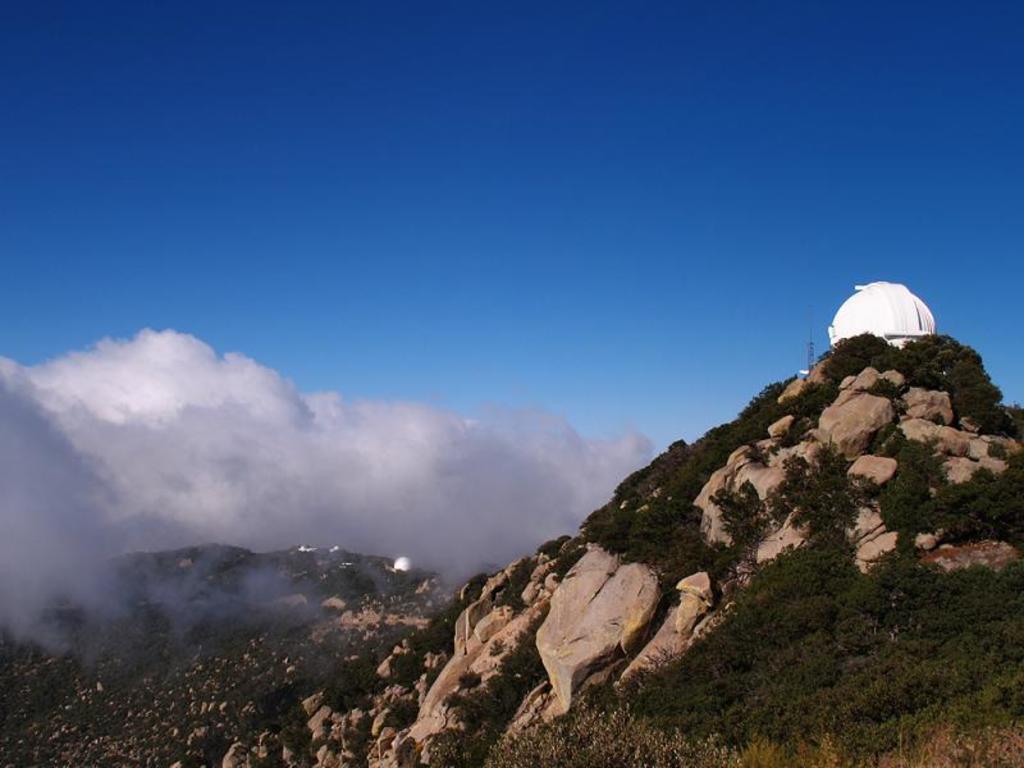In one or two sentences, can you explain what this image depicts? In this image there are trees on the rocky mountains, on the top of the mountain there is a structure. In the sky there are clouds. 